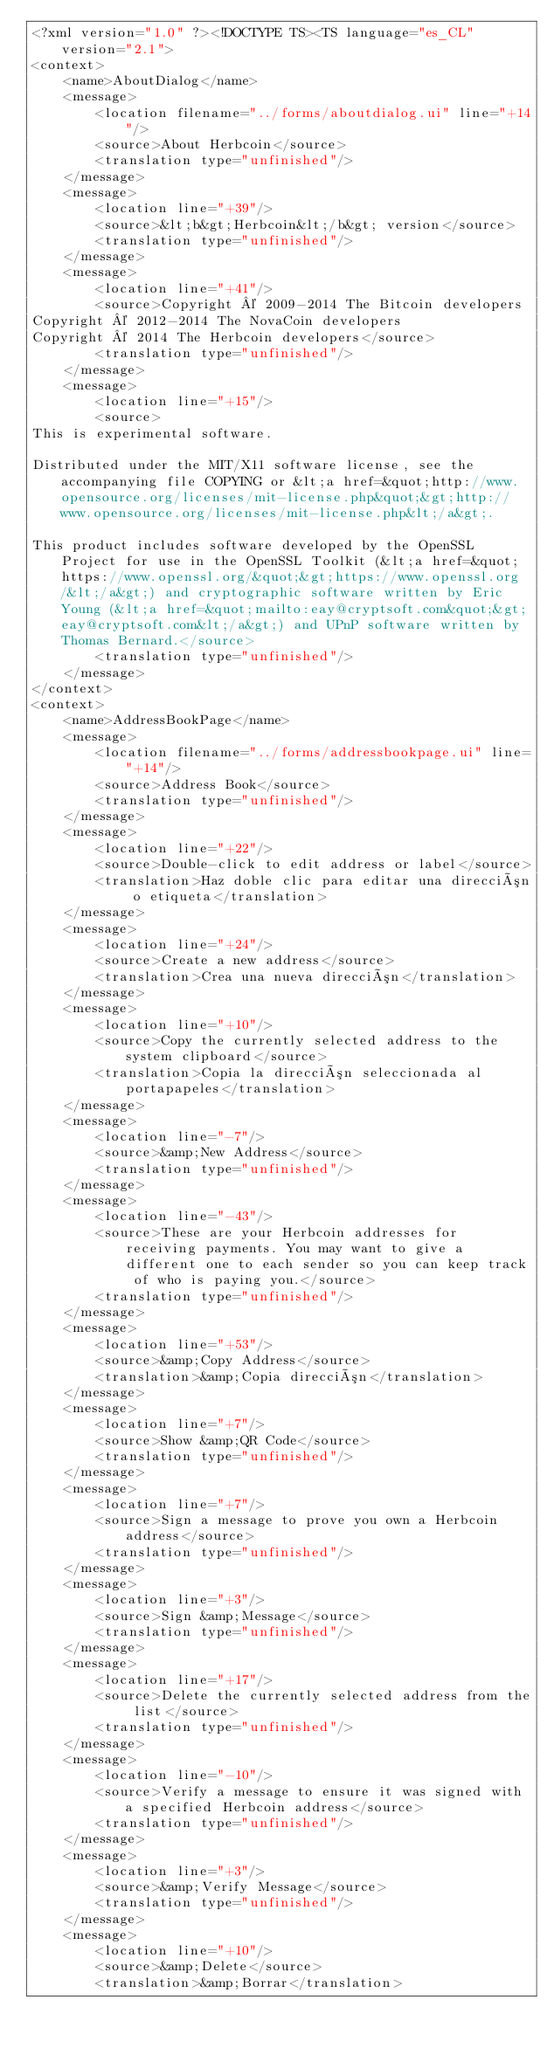<code> <loc_0><loc_0><loc_500><loc_500><_TypeScript_><?xml version="1.0" ?><!DOCTYPE TS><TS language="es_CL" version="2.1">
<context>
    <name>AboutDialog</name>
    <message>
        <location filename="../forms/aboutdialog.ui" line="+14"/>
        <source>About Herbcoin</source>
        <translation type="unfinished"/>
    </message>
    <message>
        <location line="+39"/>
        <source>&lt;b&gt;Herbcoin&lt;/b&gt; version</source>
        <translation type="unfinished"/>
    </message>
    <message>
        <location line="+41"/>
        <source>Copyright © 2009-2014 The Bitcoin developers
Copyright © 2012-2014 The NovaCoin developers
Copyright © 2014 The Herbcoin developers</source>
        <translation type="unfinished"/>
    </message>
    <message>
        <location line="+15"/>
        <source>
This is experimental software.

Distributed under the MIT/X11 software license, see the accompanying file COPYING or &lt;a href=&quot;http://www.opensource.org/licenses/mit-license.php&quot;&gt;http://www.opensource.org/licenses/mit-license.php&lt;/a&gt;.

This product includes software developed by the OpenSSL Project for use in the OpenSSL Toolkit (&lt;a href=&quot;https://www.openssl.org/&quot;&gt;https://www.openssl.org/&lt;/a&gt;) and cryptographic software written by Eric Young (&lt;a href=&quot;mailto:eay@cryptsoft.com&quot;&gt;eay@cryptsoft.com&lt;/a&gt;) and UPnP software written by Thomas Bernard.</source>
        <translation type="unfinished"/>
    </message>
</context>
<context>
    <name>AddressBookPage</name>
    <message>
        <location filename="../forms/addressbookpage.ui" line="+14"/>
        <source>Address Book</source>
        <translation type="unfinished"/>
    </message>
    <message>
        <location line="+22"/>
        <source>Double-click to edit address or label</source>
        <translation>Haz doble clic para editar una dirección o etiqueta</translation>
    </message>
    <message>
        <location line="+24"/>
        <source>Create a new address</source>
        <translation>Crea una nueva dirección</translation>
    </message>
    <message>
        <location line="+10"/>
        <source>Copy the currently selected address to the system clipboard</source>
        <translation>Copia la dirección seleccionada al portapapeles</translation>
    </message>
    <message>
        <location line="-7"/>
        <source>&amp;New Address</source>
        <translation type="unfinished"/>
    </message>
    <message>
        <location line="-43"/>
        <source>These are your Herbcoin addresses for receiving payments. You may want to give a different one to each sender so you can keep track of who is paying you.</source>
        <translation type="unfinished"/>
    </message>
    <message>
        <location line="+53"/>
        <source>&amp;Copy Address</source>
        <translation>&amp;Copia dirección</translation>
    </message>
    <message>
        <location line="+7"/>
        <source>Show &amp;QR Code</source>
        <translation type="unfinished"/>
    </message>
    <message>
        <location line="+7"/>
        <source>Sign a message to prove you own a Herbcoin address</source>
        <translation type="unfinished"/>
    </message>
    <message>
        <location line="+3"/>
        <source>Sign &amp;Message</source>
        <translation type="unfinished"/>
    </message>
    <message>
        <location line="+17"/>
        <source>Delete the currently selected address from the list</source>
        <translation type="unfinished"/>
    </message>
    <message>
        <location line="-10"/>
        <source>Verify a message to ensure it was signed with a specified Herbcoin address</source>
        <translation type="unfinished"/>
    </message>
    <message>
        <location line="+3"/>
        <source>&amp;Verify Message</source>
        <translation type="unfinished"/>
    </message>
    <message>
        <location line="+10"/>
        <source>&amp;Delete</source>
        <translation>&amp;Borrar</translation></code> 